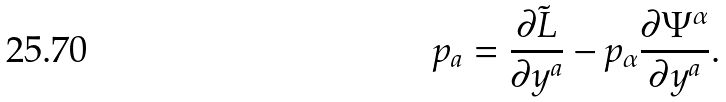Convert formula to latex. <formula><loc_0><loc_0><loc_500><loc_500>p _ { a } = \frac { \partial \tilde { L } } { \partial y ^ { a } } - p _ { \alpha } \frac { \partial \Psi ^ { \alpha } } { \partial y ^ { a } } .</formula> 